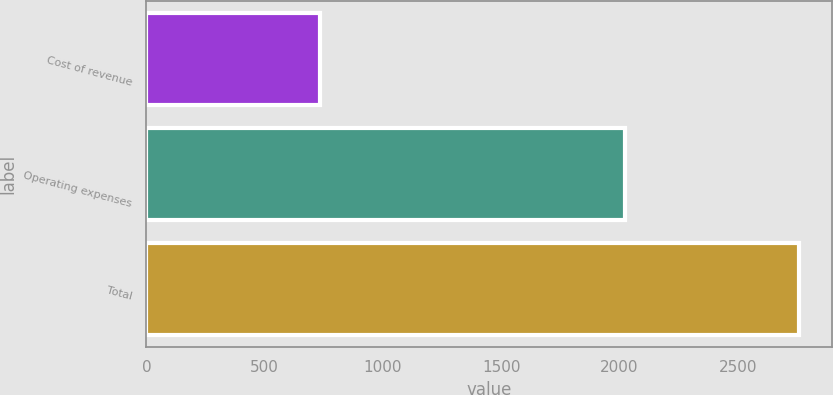<chart> <loc_0><loc_0><loc_500><loc_500><bar_chart><fcel>Cost of revenue<fcel>Operating expenses<fcel>Total<nl><fcel>735.9<fcel>2024.9<fcel>2760.8<nl></chart> 